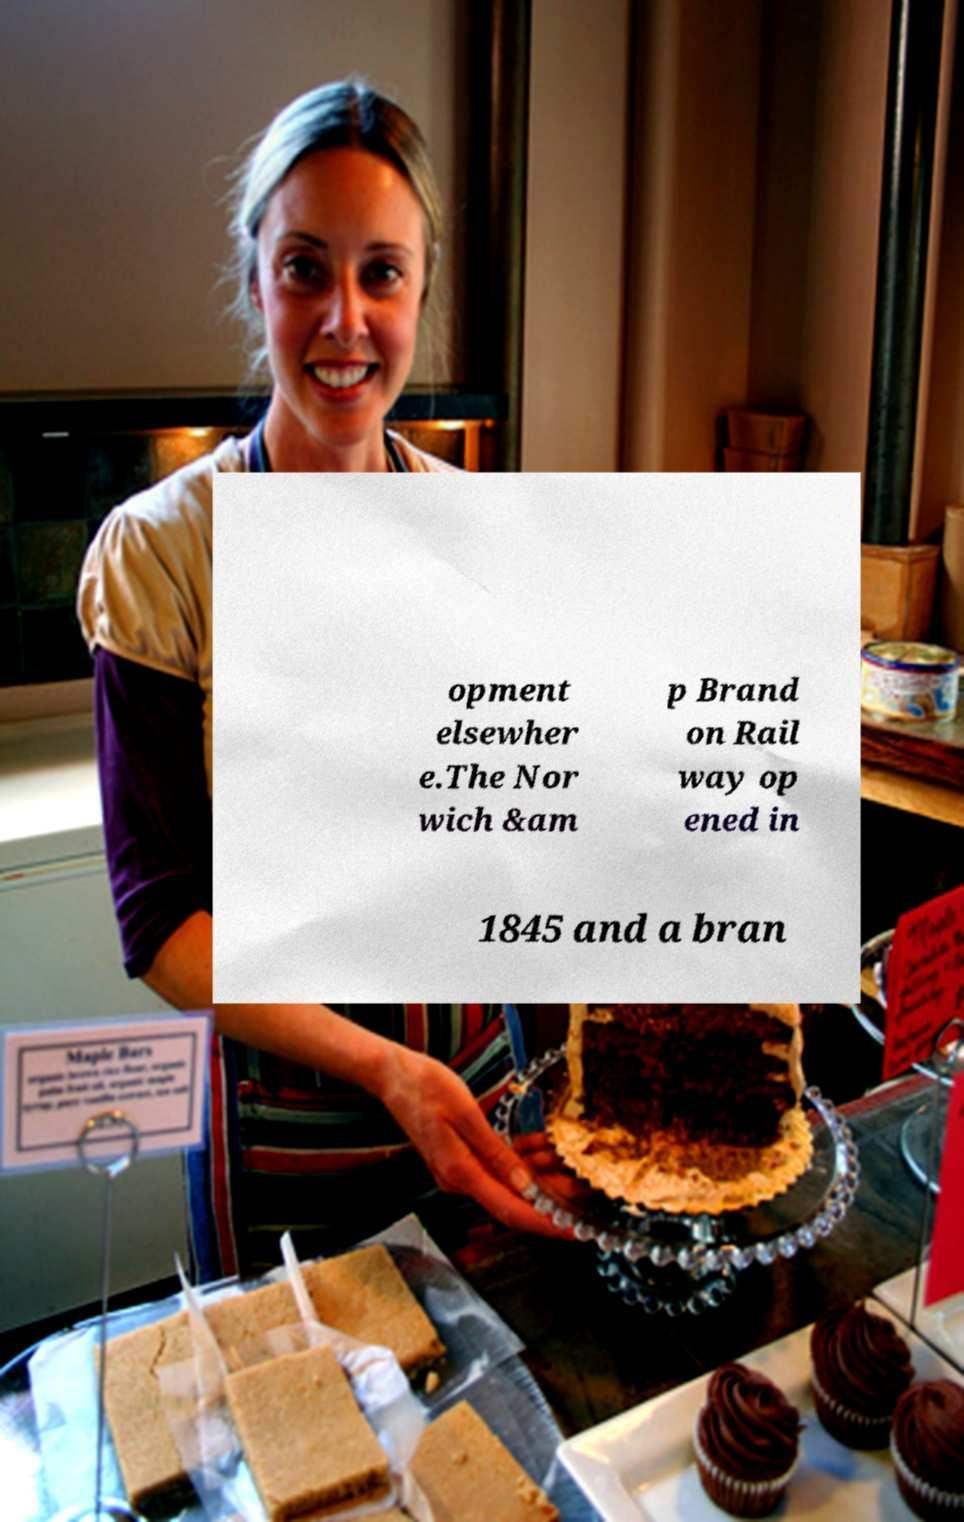Please read and relay the text visible in this image. What does it say? opment elsewher e.The Nor wich &am p Brand on Rail way op ened in 1845 and a bran 